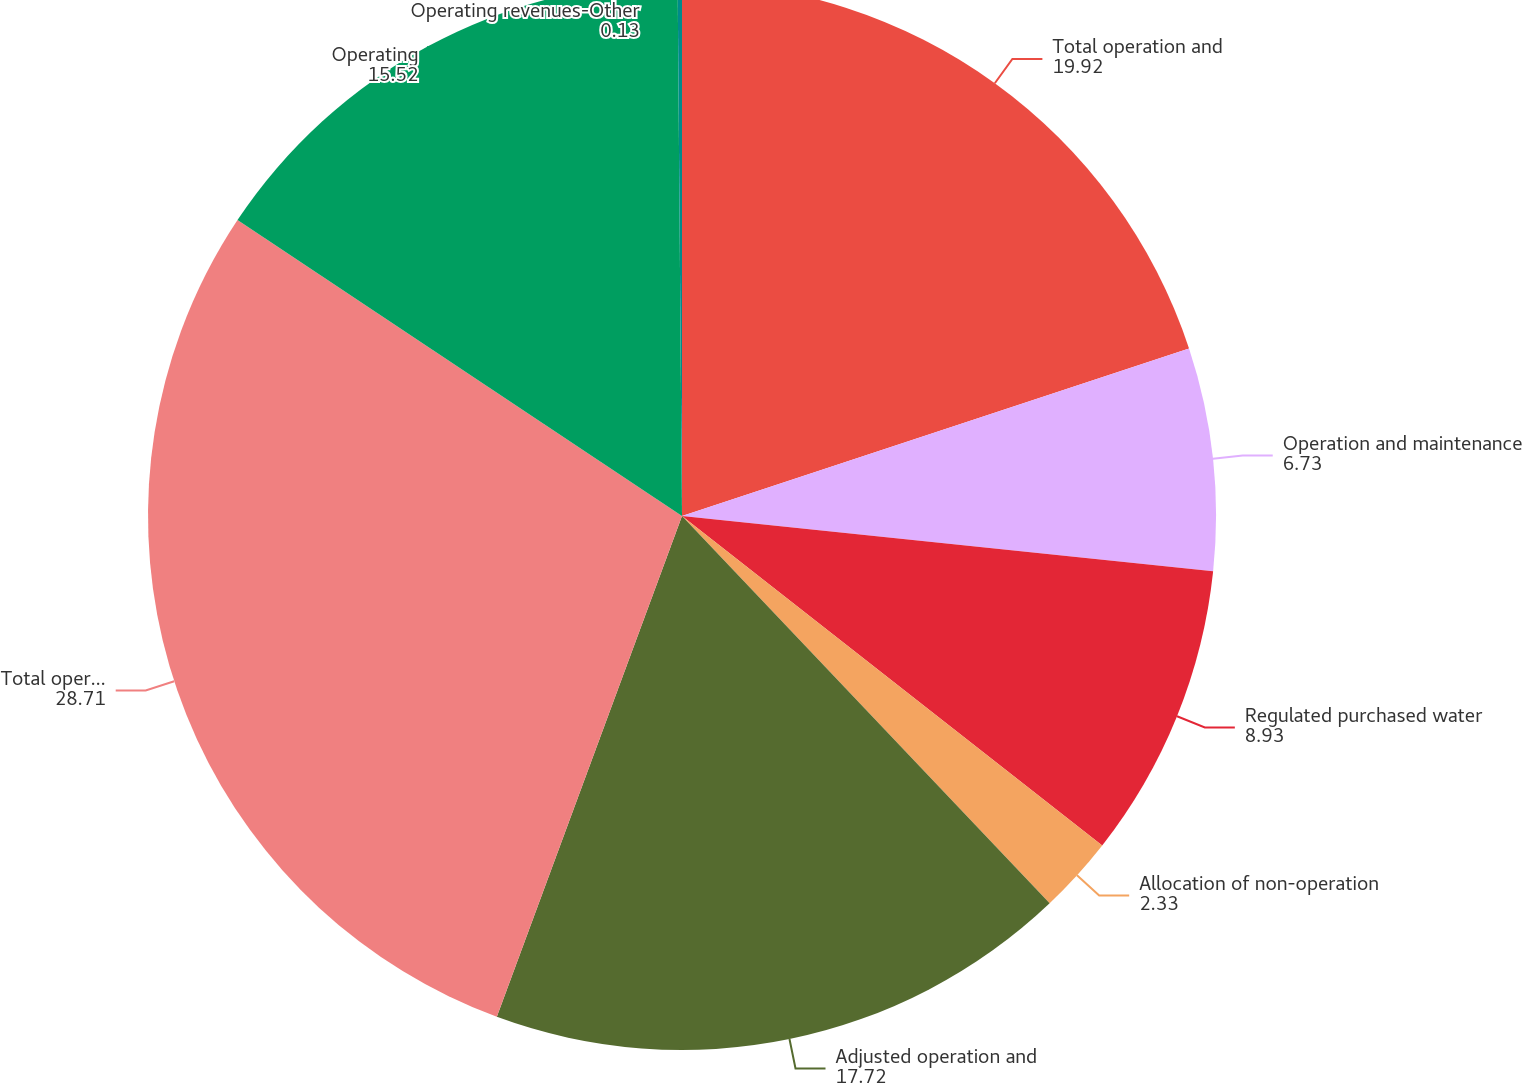Convert chart to OTSL. <chart><loc_0><loc_0><loc_500><loc_500><pie_chart><fcel>Total operation and<fcel>Operation and maintenance<fcel>Regulated purchased water<fcel>Allocation of non-operation<fcel>Adjusted operation and<fcel>Total operating revenues<fcel>Operating<fcel>Operating revenues-Other<nl><fcel>19.92%<fcel>6.73%<fcel>8.93%<fcel>2.33%<fcel>17.72%<fcel>28.71%<fcel>15.52%<fcel>0.13%<nl></chart> 